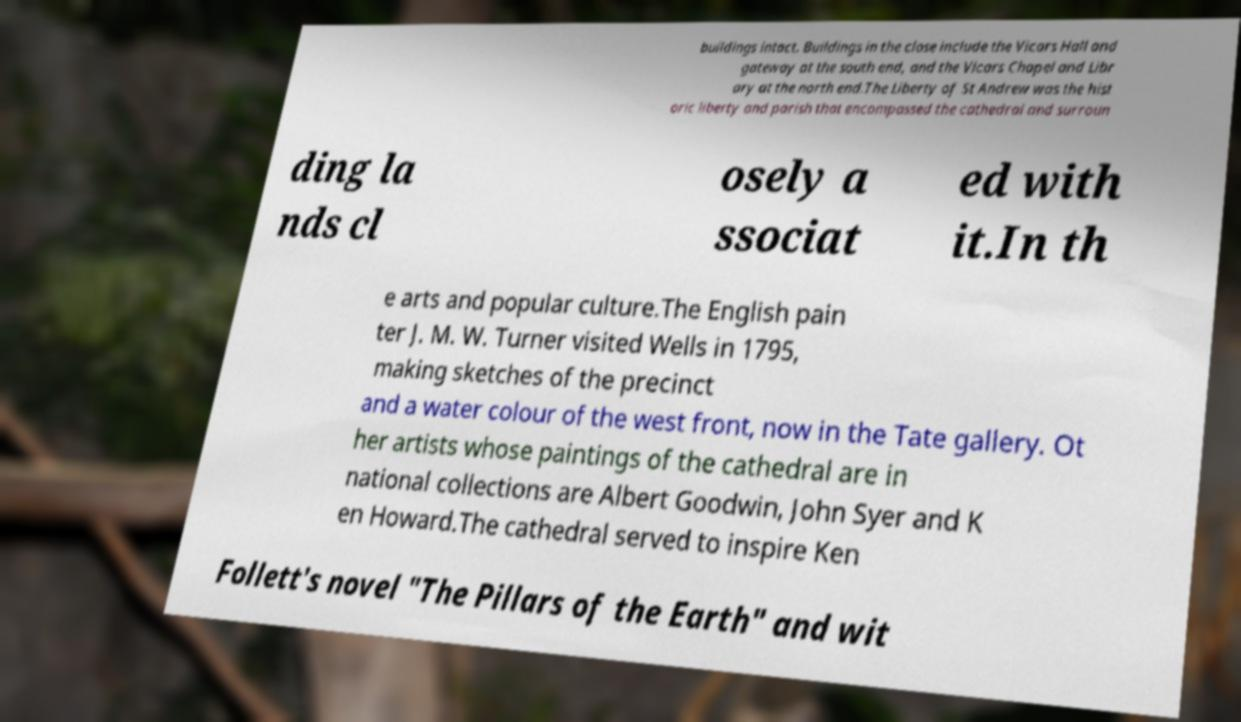Please identify and transcribe the text found in this image. buildings intact. Buildings in the close include the Vicars Hall and gateway at the south end, and the Vicars Chapel and Libr ary at the north end.The Liberty of St Andrew was the hist oric liberty and parish that encompassed the cathedral and surroun ding la nds cl osely a ssociat ed with it.In th e arts and popular culture.The English pain ter J. M. W. Turner visited Wells in 1795, making sketches of the precinct and a water colour of the west front, now in the Tate gallery. Ot her artists whose paintings of the cathedral are in national collections are Albert Goodwin, John Syer and K en Howard.The cathedral served to inspire Ken Follett's novel "The Pillars of the Earth" and wit 